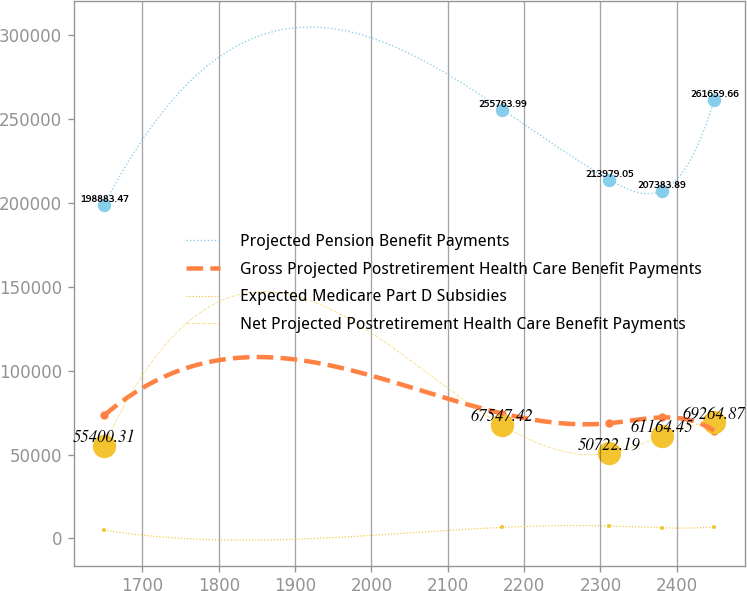Convert chart to OTSL. <chart><loc_0><loc_0><loc_500><loc_500><line_chart><ecel><fcel>Projected Pension Benefit Payments<fcel>Gross Projected Postretirement Health Care Benefit Payments<fcel>Expected Medicare Part D Subsidies<fcel>Net Projected Postretirement Health Care Benefit Payments<nl><fcel>1649.75<fcel>198883<fcel>73403.5<fcel>5011.83<fcel>55400.3<nl><fcel>2171.48<fcel>255764<fcel>74510<fcel>6617.21<fcel>67547.4<nl><fcel>2311.56<fcel>213979<fcel>68732.6<fcel>7471.29<fcel>50722.2<nl><fcel>2380.3<fcel>207384<fcel>72191.8<fcel>6342.73<fcel>61164.4<nl><fcel>2449.04<fcel>261660<fcel>64303.6<fcel>6870.96<fcel>69264.9<nl></chart> 